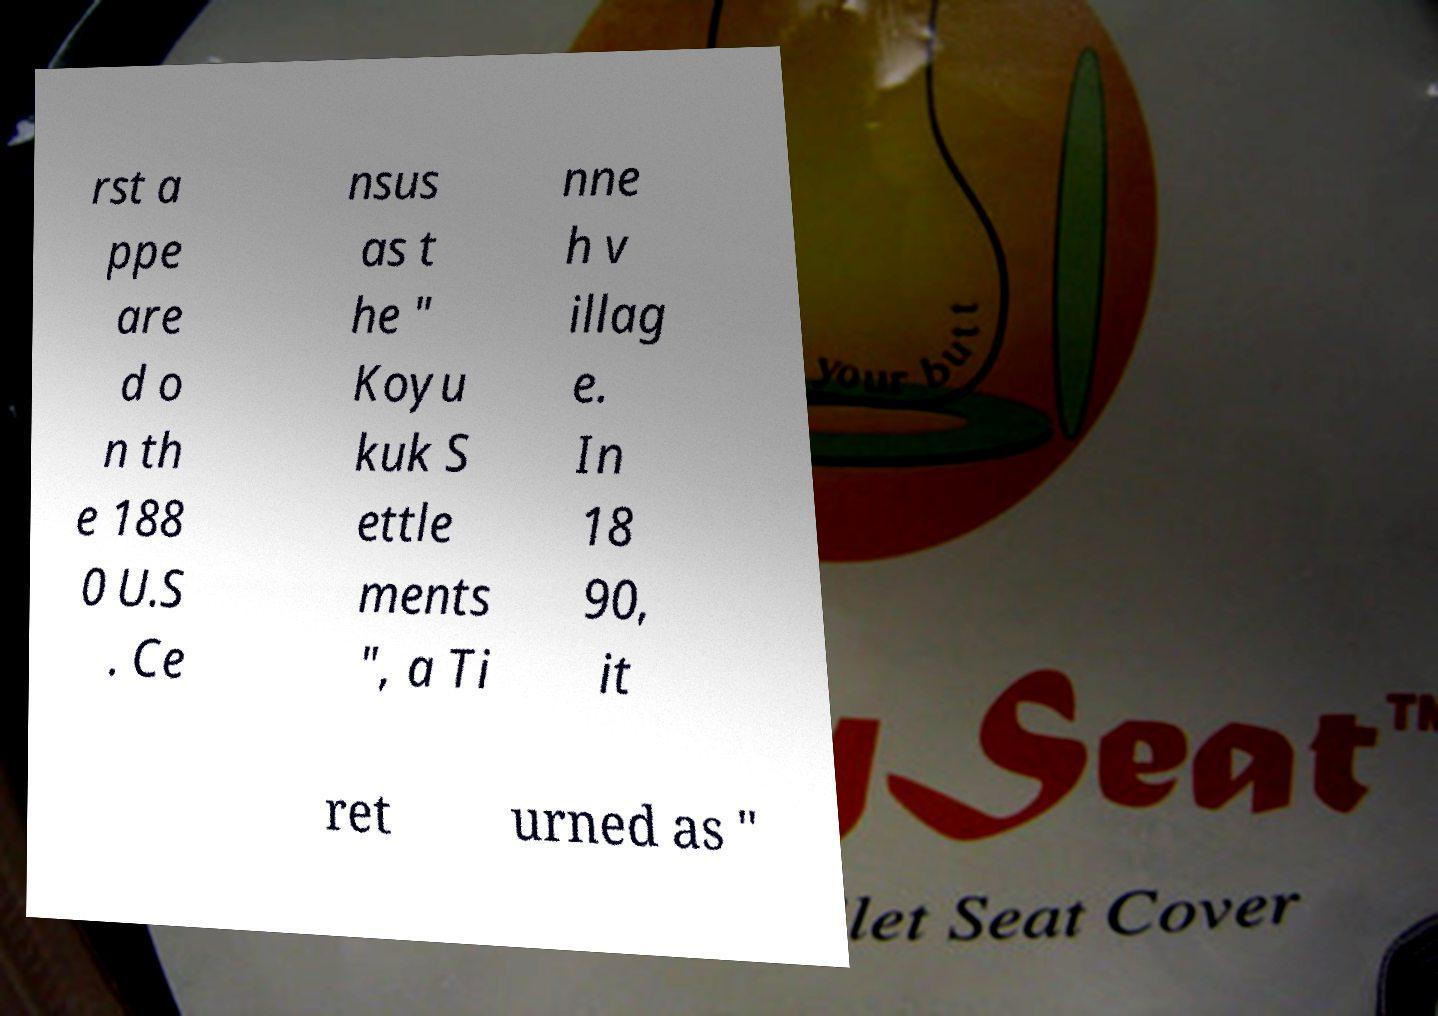Can you accurately transcribe the text from the provided image for me? rst a ppe are d o n th e 188 0 U.S . Ce nsus as t he " Koyu kuk S ettle ments ", a Ti nne h v illag e. In 18 90, it ret urned as " 